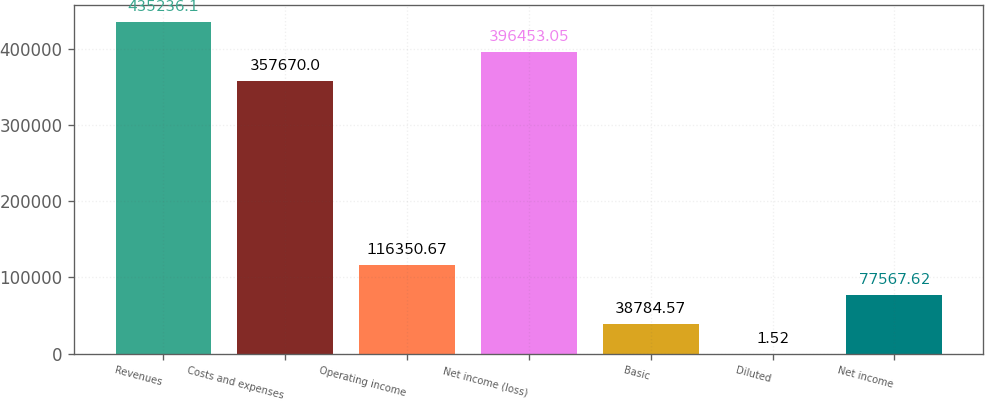<chart> <loc_0><loc_0><loc_500><loc_500><bar_chart><fcel>Revenues<fcel>Costs and expenses<fcel>Operating income<fcel>Net income (loss)<fcel>Basic<fcel>Diluted<fcel>Net income<nl><fcel>435236<fcel>357670<fcel>116351<fcel>396453<fcel>38784.6<fcel>1.52<fcel>77567.6<nl></chart> 